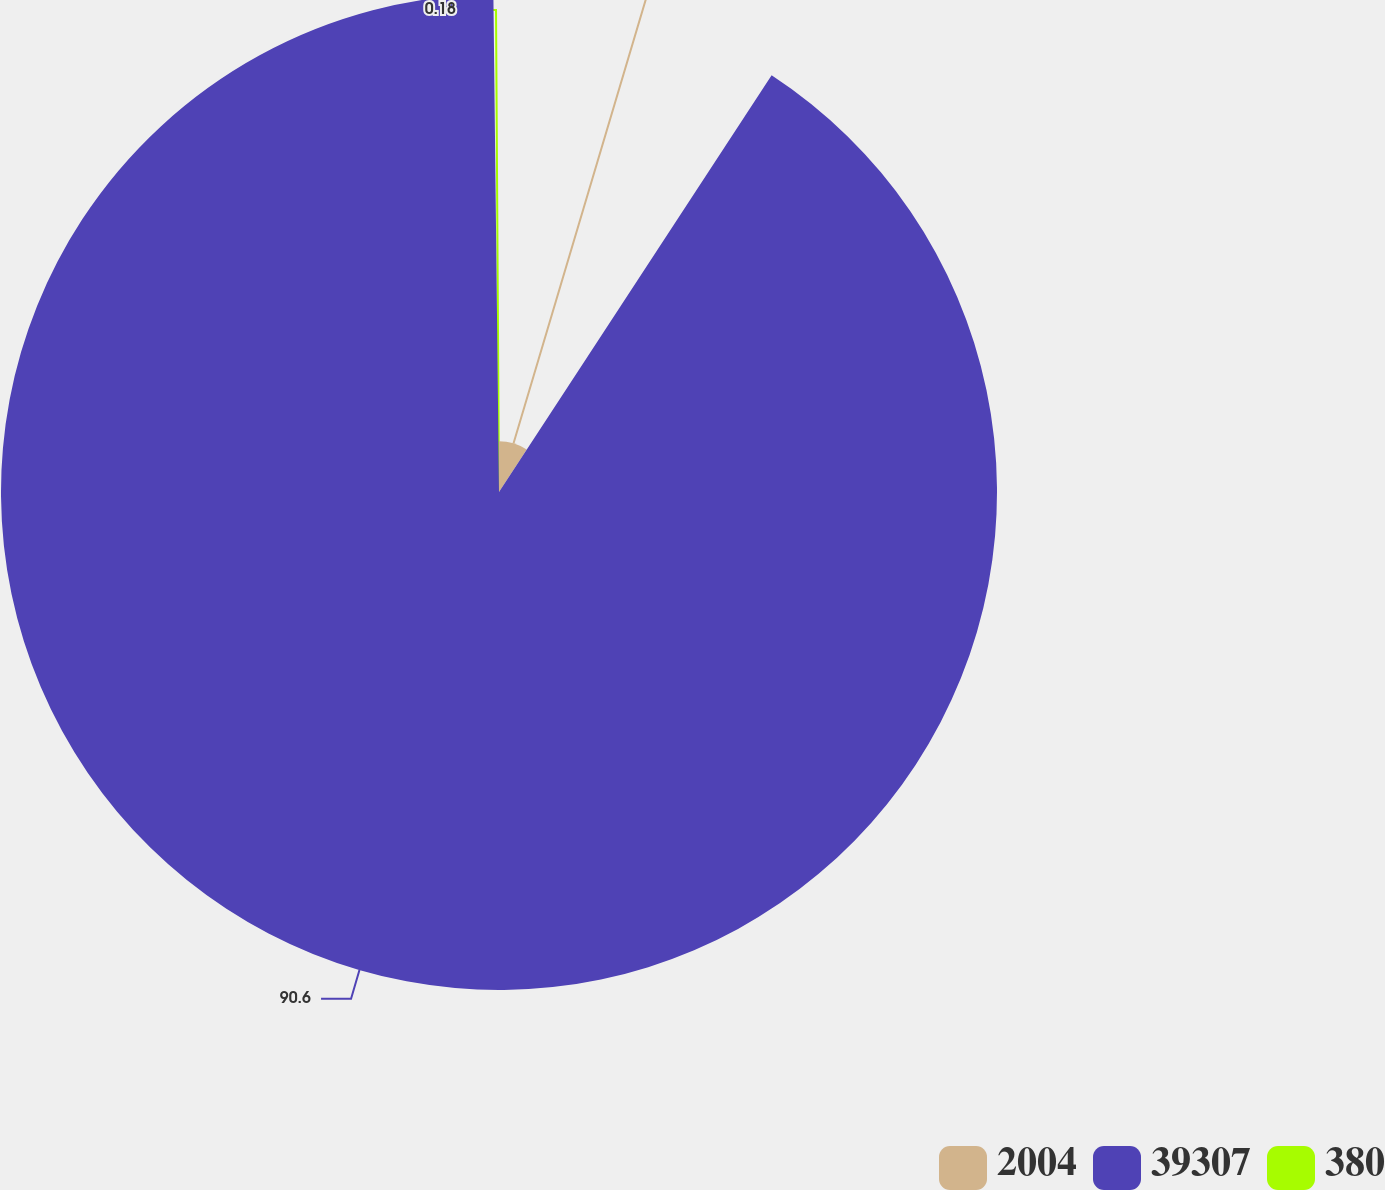Convert chart. <chart><loc_0><loc_0><loc_500><loc_500><pie_chart><fcel>2004<fcel>39307<fcel>380<nl><fcel>9.22%<fcel>90.6%<fcel>0.18%<nl></chart> 